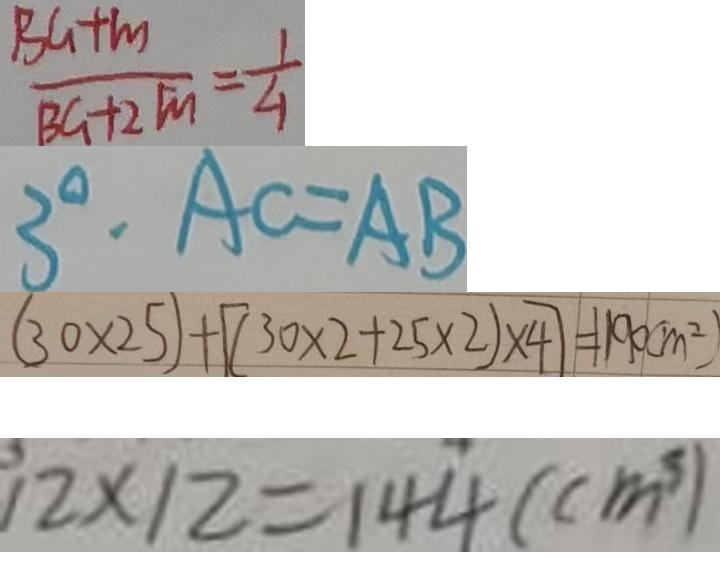<formula> <loc_0><loc_0><loc_500><loc_500>\frac { B G + m } { B G + 2 m } = \frac { 1 } { 4 } 
 3 ^ { \circ } \cdot A C = A B 
 ( 3 0 \times 2 5 ) + [ ( 3 0 \times 2 + 2 5 \times 2 ) \times 4 ] = 1 1 9 0 ( m ^ { 2 } ) 
 1 2 \times 1 2 = 1 4 4 ( c m ^ { 3 } )</formula> 